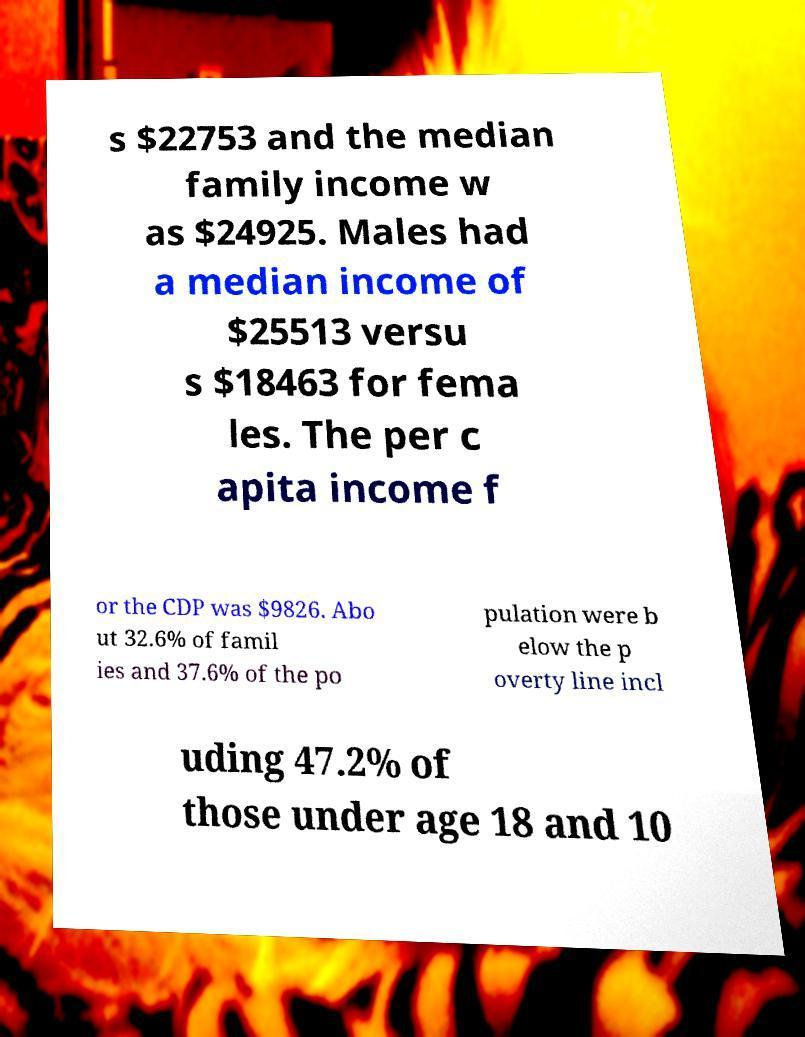I need the written content from this picture converted into text. Can you do that? s $22753 and the median family income w as $24925. Males had a median income of $25513 versu s $18463 for fema les. The per c apita income f or the CDP was $9826. Abo ut 32.6% of famil ies and 37.6% of the po pulation were b elow the p overty line incl uding 47.2% of those under age 18 and 10 